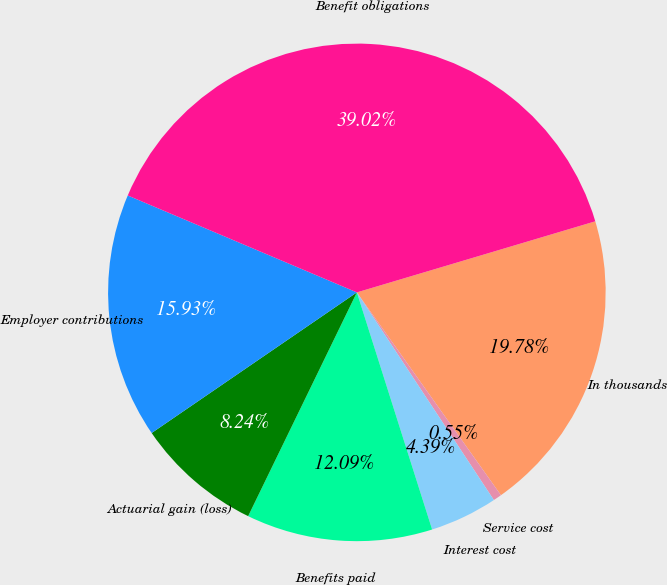Convert chart to OTSL. <chart><loc_0><loc_0><loc_500><loc_500><pie_chart><fcel>In thousands<fcel>Service cost<fcel>Interest cost<fcel>Benefits paid<fcel>Actuarial gain (loss)<fcel>Employer contributions<fcel>Benefit obligations<nl><fcel>19.78%<fcel>0.55%<fcel>4.39%<fcel>12.09%<fcel>8.24%<fcel>15.93%<fcel>39.02%<nl></chart> 